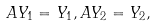<formula> <loc_0><loc_0><loc_500><loc_500>A Y _ { 1 } & = Y _ { 1 } , A Y _ { 2 } = Y _ { 2 } ,</formula> 